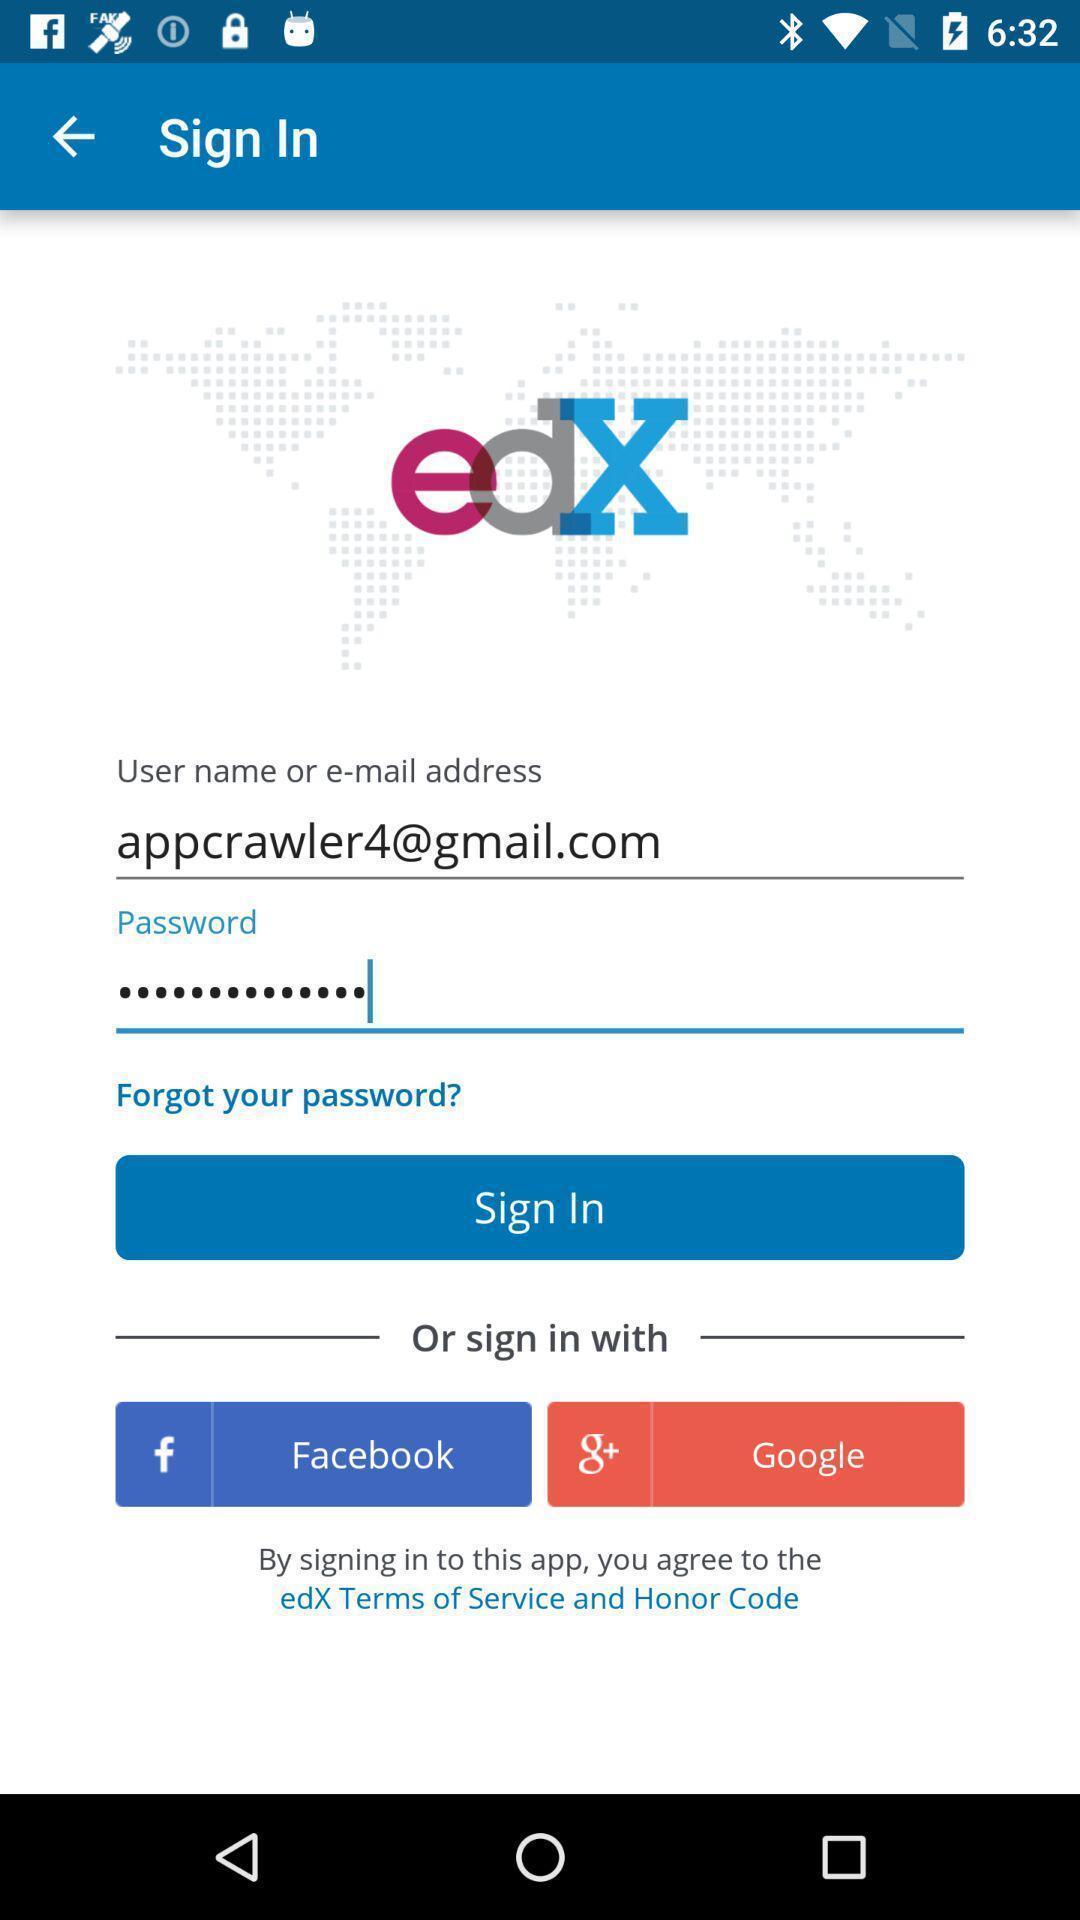Explain what's happening in this screen capture. Sign in page of a online learning app. 